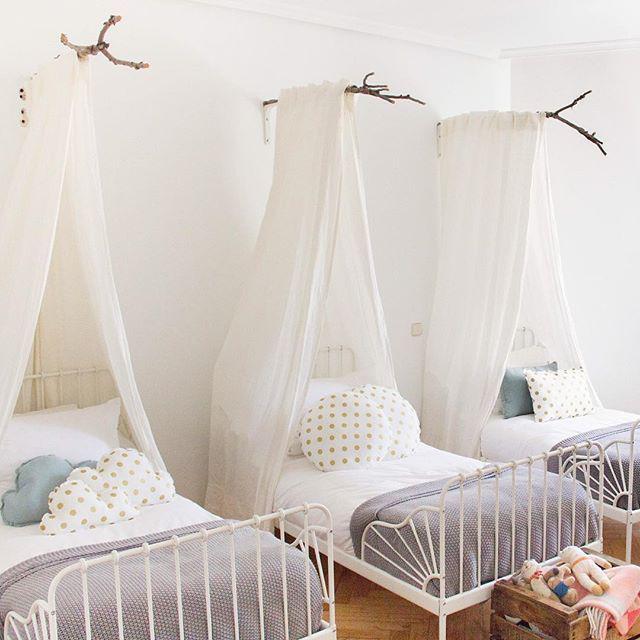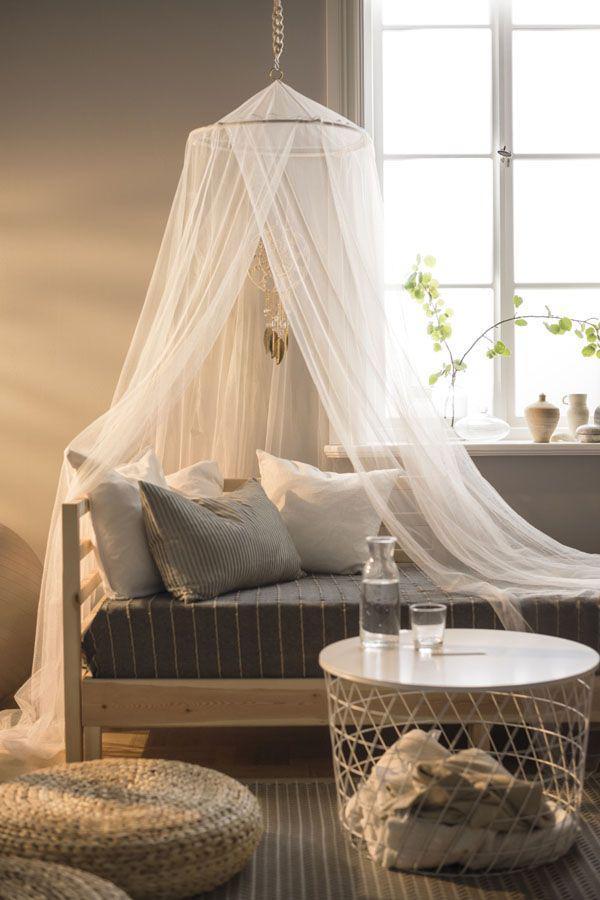The first image is the image on the left, the second image is the image on the right. Analyze the images presented: Is the assertion "There are two beds in total." valid? Answer yes or no. No. 